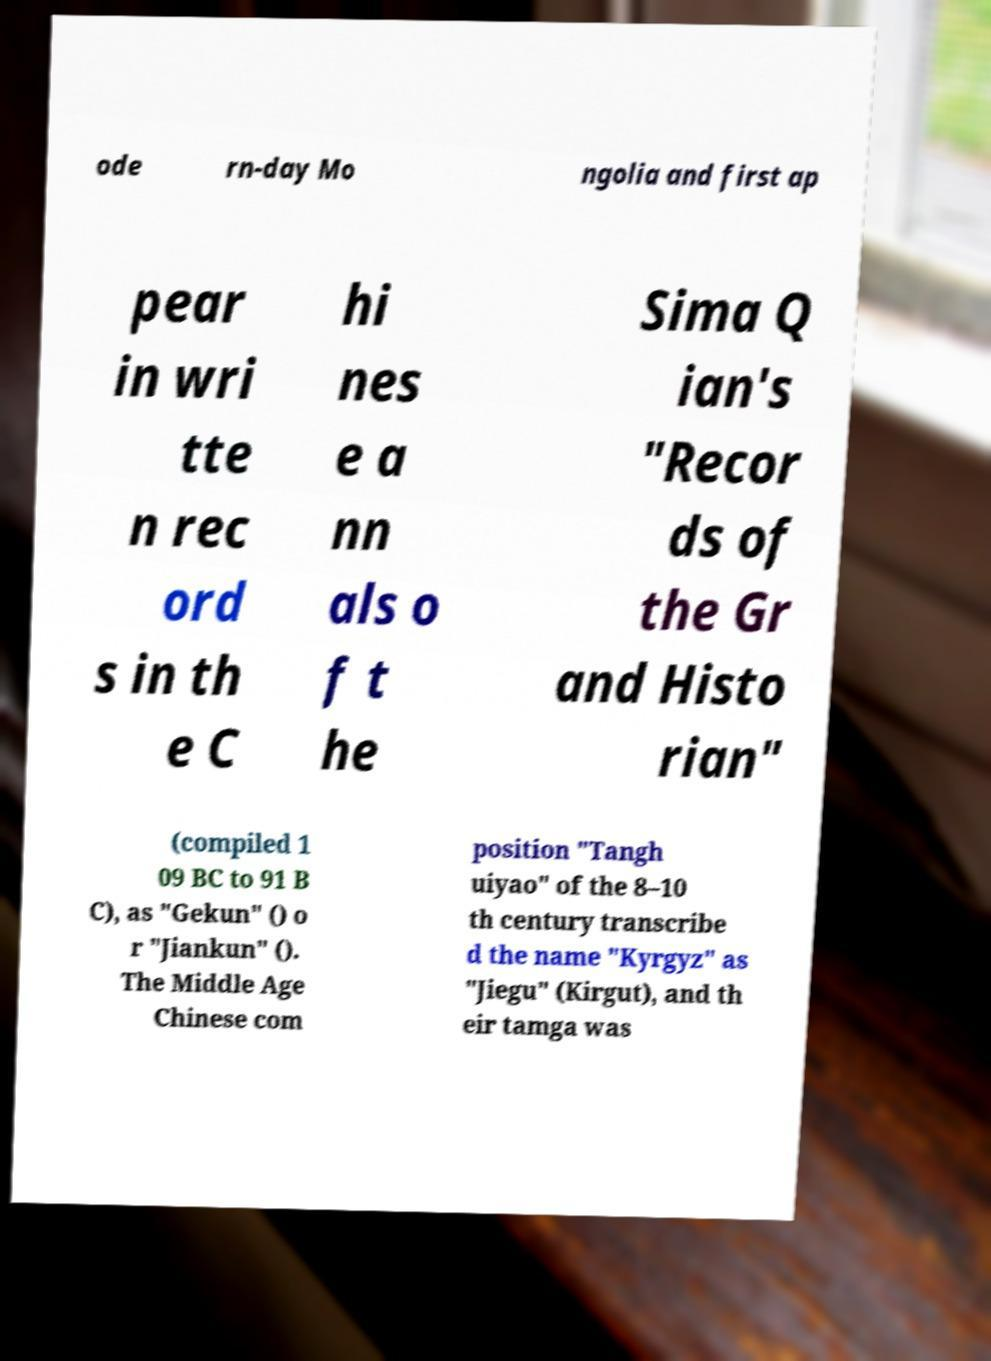There's text embedded in this image that I need extracted. Can you transcribe it verbatim? ode rn-day Mo ngolia and first ap pear in wri tte n rec ord s in th e C hi nes e a nn als o f t he Sima Q ian's "Recor ds of the Gr and Histo rian" (compiled 1 09 BC to 91 B C), as "Gekun" () o r "Jiankun" (). The Middle Age Chinese com position "Tangh uiyao" of the 8–10 th century transcribe d the name "Kyrgyz" as "Jiegu" (Kirgut), and th eir tamga was 